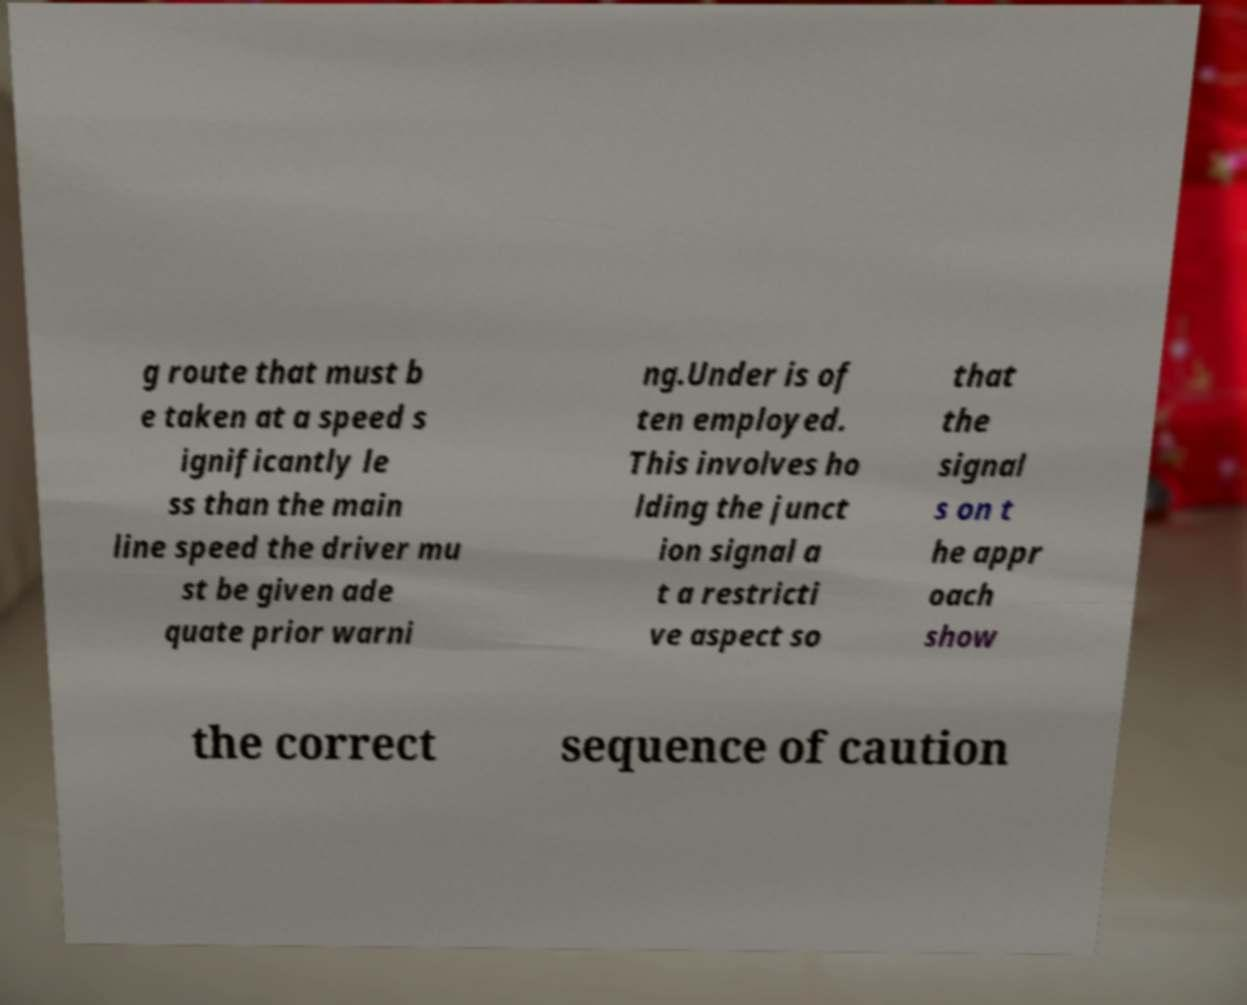Can you read and provide the text displayed in the image?This photo seems to have some interesting text. Can you extract and type it out for me? g route that must b e taken at a speed s ignificantly le ss than the main line speed the driver mu st be given ade quate prior warni ng.Under is of ten employed. This involves ho lding the junct ion signal a t a restricti ve aspect so that the signal s on t he appr oach show the correct sequence of caution 